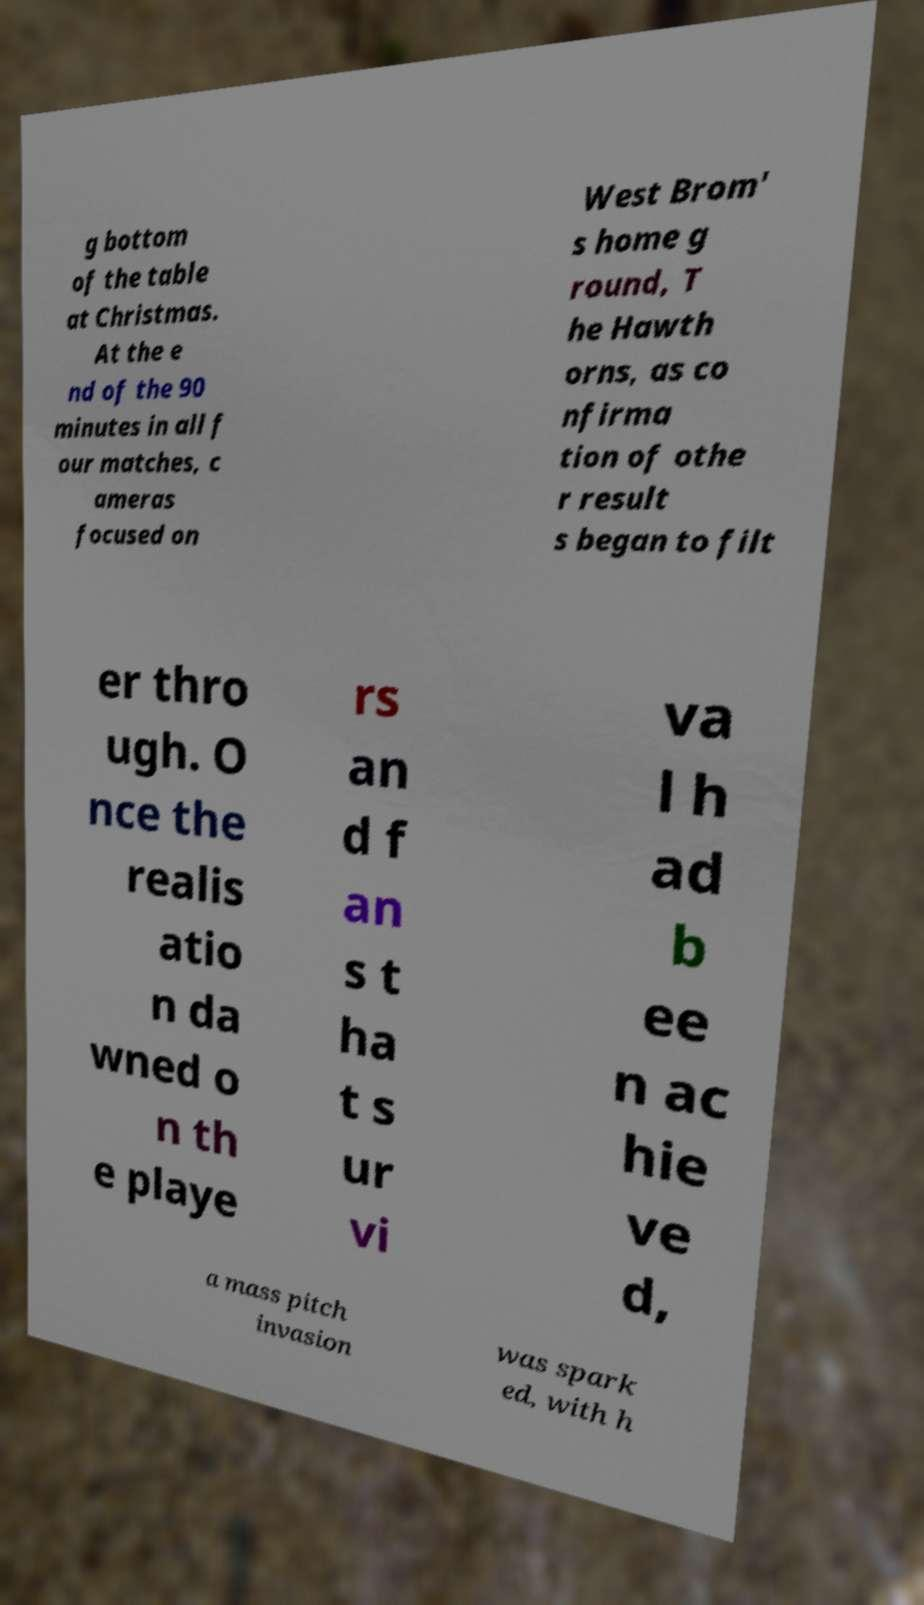There's text embedded in this image that I need extracted. Can you transcribe it verbatim? g bottom of the table at Christmas. At the e nd of the 90 minutes in all f our matches, c ameras focused on West Brom' s home g round, T he Hawth orns, as co nfirma tion of othe r result s began to filt er thro ugh. O nce the realis atio n da wned o n th e playe rs an d f an s t ha t s ur vi va l h ad b ee n ac hie ve d, a mass pitch invasion was spark ed, with h 